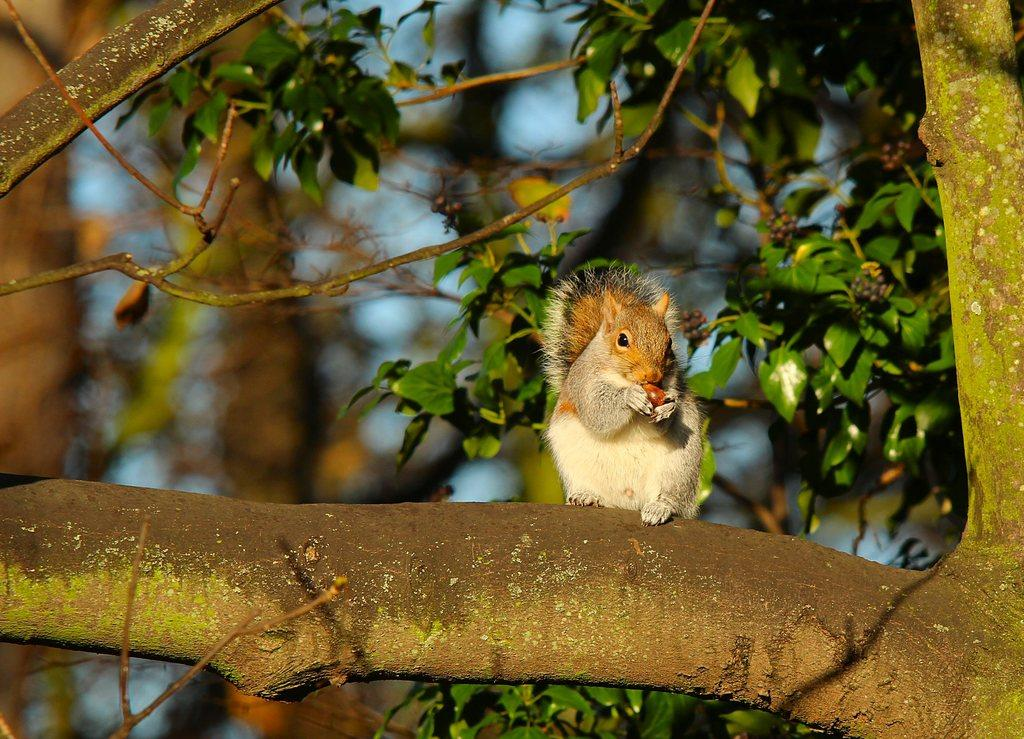What animal can be seen in the image? There is a squirrel in the image. Where is the squirrel located? The squirrel is sitting on a tree branch. What is the squirrel holding in its hands? The squirrel is holding a fruit in its hands. What can be seen in the background of the image? There are trees with fruits in the background of the image, and the sky is visible. How many bikes can be seen in the image? There are no bikes present in the image. What type of snails can be seen crawling on the tree branch? There are no snails visible in the image; only the squirrel and the fruit are present. 